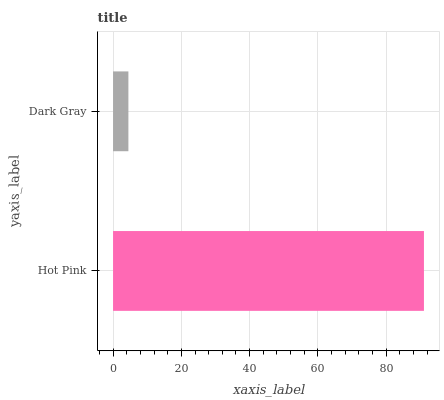Is Dark Gray the minimum?
Answer yes or no. Yes. Is Hot Pink the maximum?
Answer yes or no. Yes. Is Dark Gray the maximum?
Answer yes or no. No. Is Hot Pink greater than Dark Gray?
Answer yes or no. Yes. Is Dark Gray less than Hot Pink?
Answer yes or no. Yes. Is Dark Gray greater than Hot Pink?
Answer yes or no. No. Is Hot Pink less than Dark Gray?
Answer yes or no. No. Is Hot Pink the high median?
Answer yes or no. Yes. Is Dark Gray the low median?
Answer yes or no. Yes. Is Dark Gray the high median?
Answer yes or no. No. Is Hot Pink the low median?
Answer yes or no. No. 